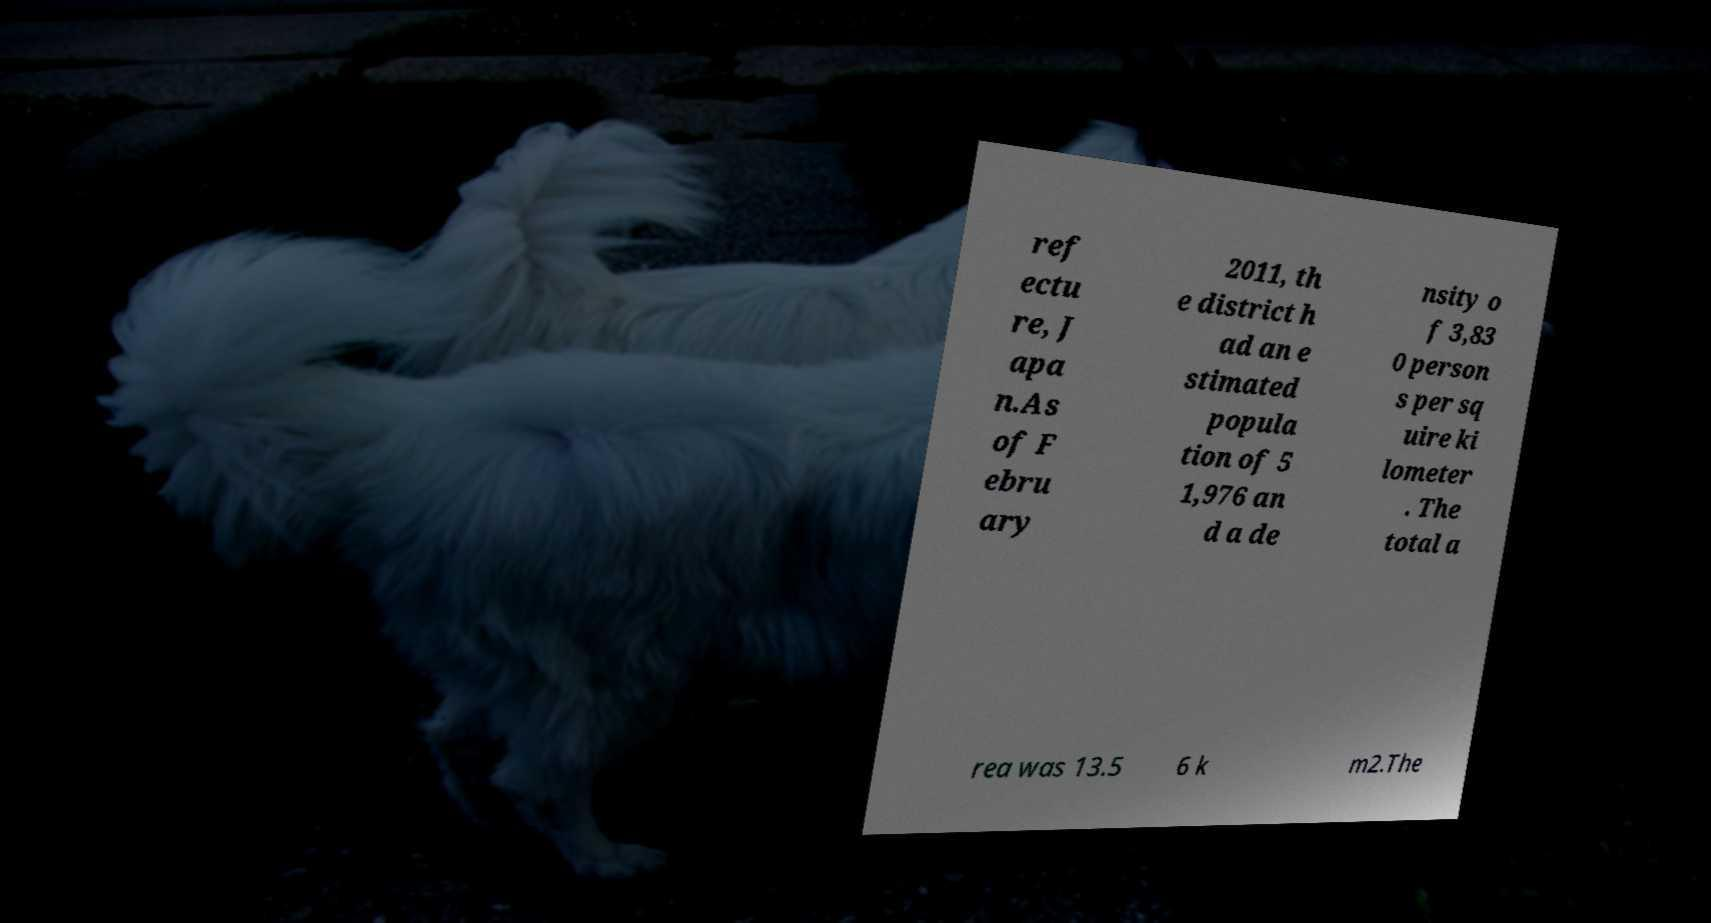Please identify and transcribe the text found in this image. ref ectu re, J apa n.As of F ebru ary 2011, th e district h ad an e stimated popula tion of 5 1,976 an d a de nsity o f 3,83 0 person s per sq uire ki lometer . The total a rea was 13.5 6 k m2.The 